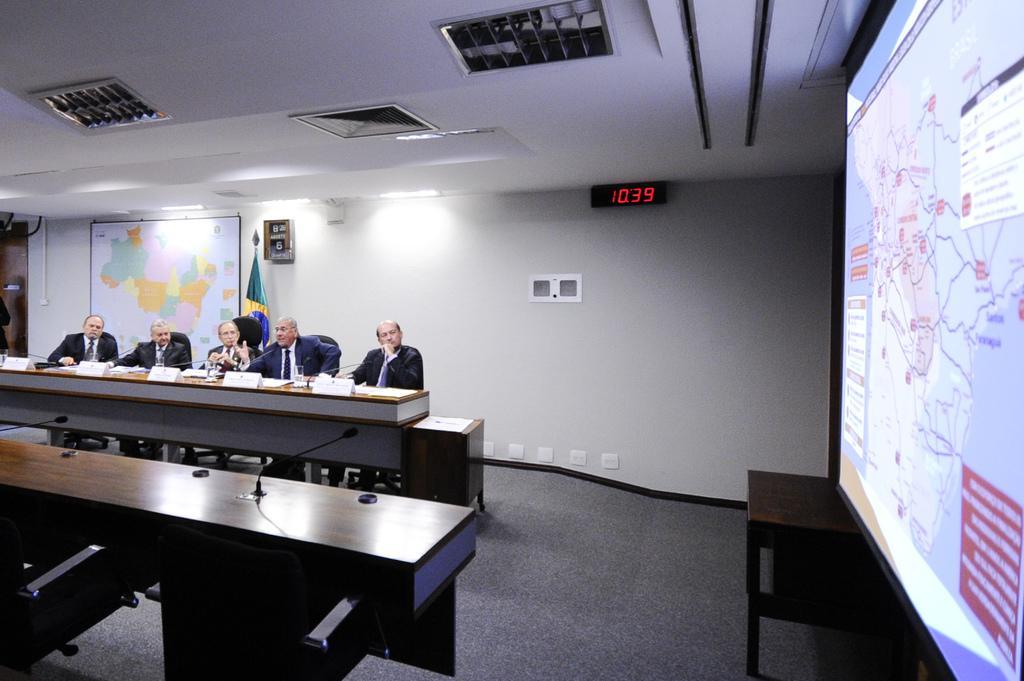In one or two sentences, can you explain what this image depicts? Five persons are sitting on the chairs behind them there is a world map and a light. On the right there is a projected image. 